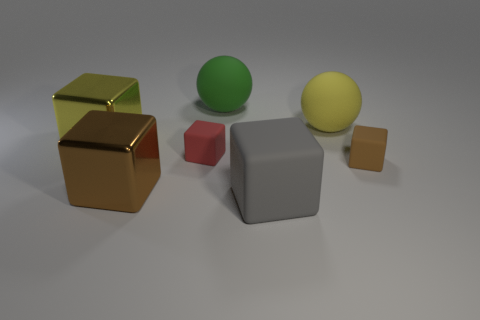Are there an equal number of tiny red rubber blocks that are to the left of the big yellow shiny cube and large gray rubber blocks?
Offer a very short reply. No. What number of large metal cubes are the same color as the large rubber cube?
Offer a very short reply. 0. The other small object that is the same shape as the small brown object is what color?
Offer a terse response. Red. Do the gray object and the green object have the same size?
Make the answer very short. Yes. Are there an equal number of tiny red rubber cubes that are behind the green ball and yellow cubes that are behind the gray rubber object?
Give a very brief answer. No. Are any small gray shiny things visible?
Provide a succinct answer. No. There is a red matte thing that is the same shape as the gray object; what size is it?
Keep it short and to the point. Small. How big is the sphere on the right side of the big gray object?
Your response must be concise. Large. Is the number of balls behind the green thing greater than the number of brown metal objects?
Your answer should be very brief. No. The red object has what shape?
Offer a very short reply. Cube. 